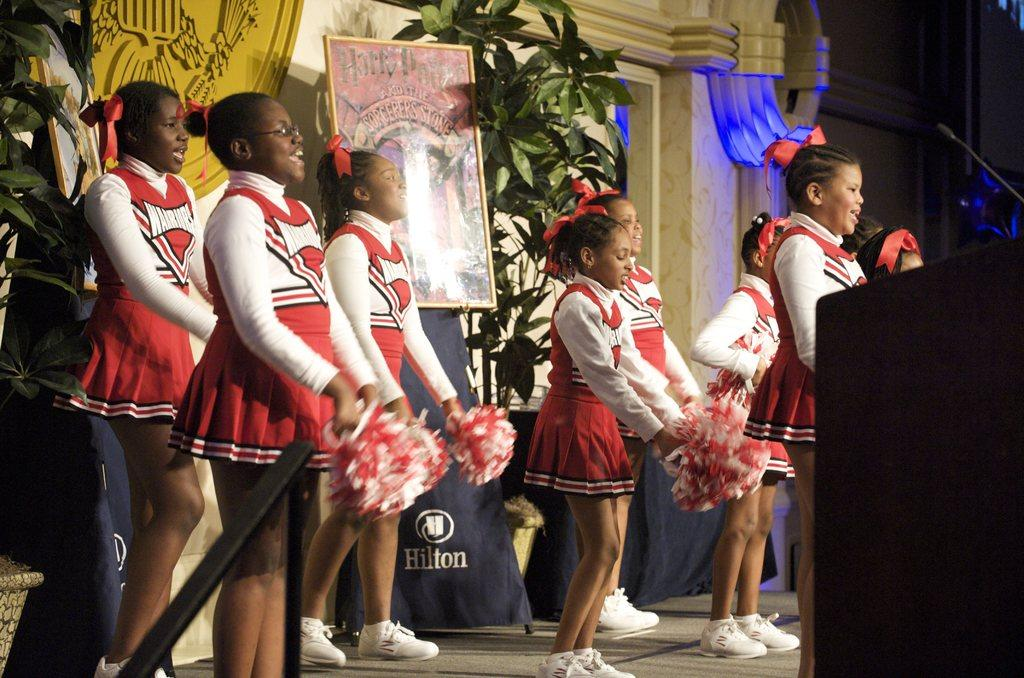Provide a one-sentence caption for the provided image. Warriors cheerleaders perform a routine in front of a Harry Potter poster. 